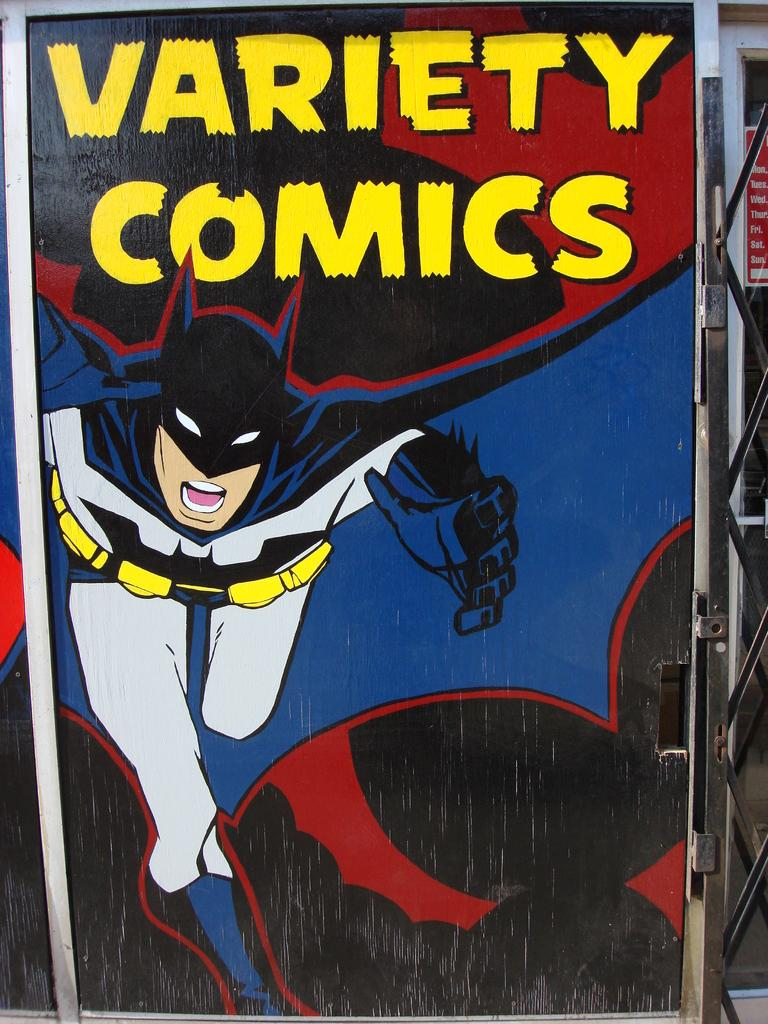What is located in the foreground of the image? There is a poster in the foreground. What is depicted on the poster? The poster contains a cartoon character. Are there any words or letters on the poster? Yes, there is text on the poster. What can be seen on the right side of the image? There appears to be a metal gate on the right side. What type of card is being used to cover the quilt in the image? There is no card or quilt present in the image. Can you hear any sound coming from the cartoon character on the poster? The image is static, so there is no sound present. 